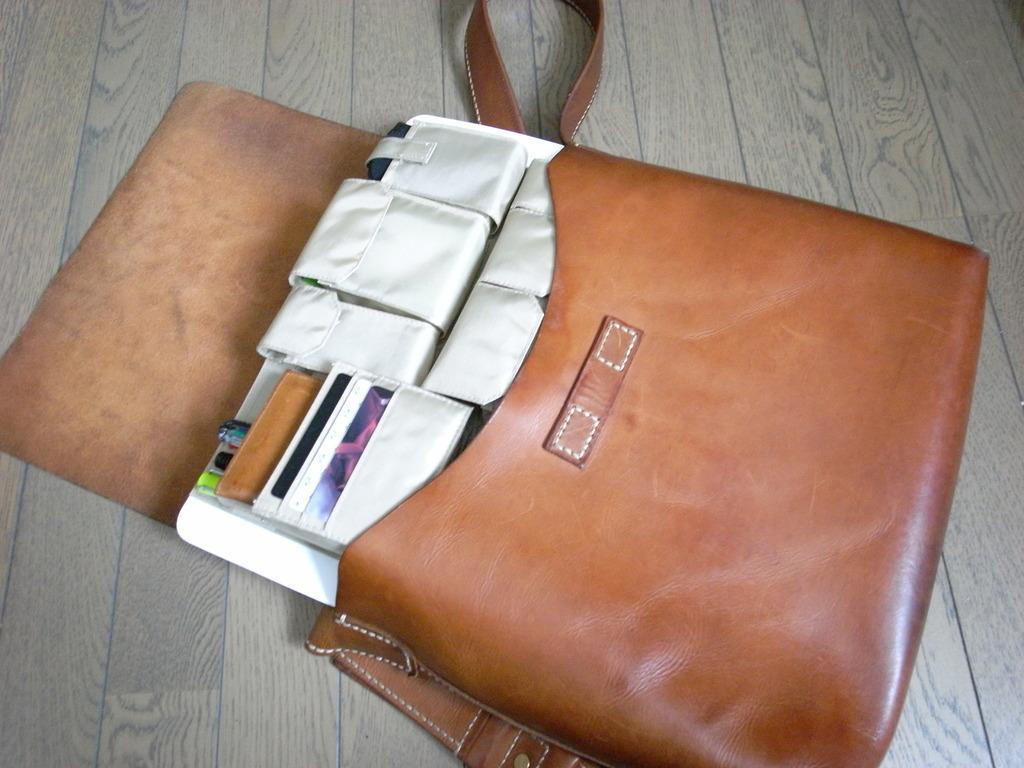In one or two sentences, can you explain what this image depicts? In this image, There is a table on that table there is a bag which is in brown color in that there are some white color objects. 